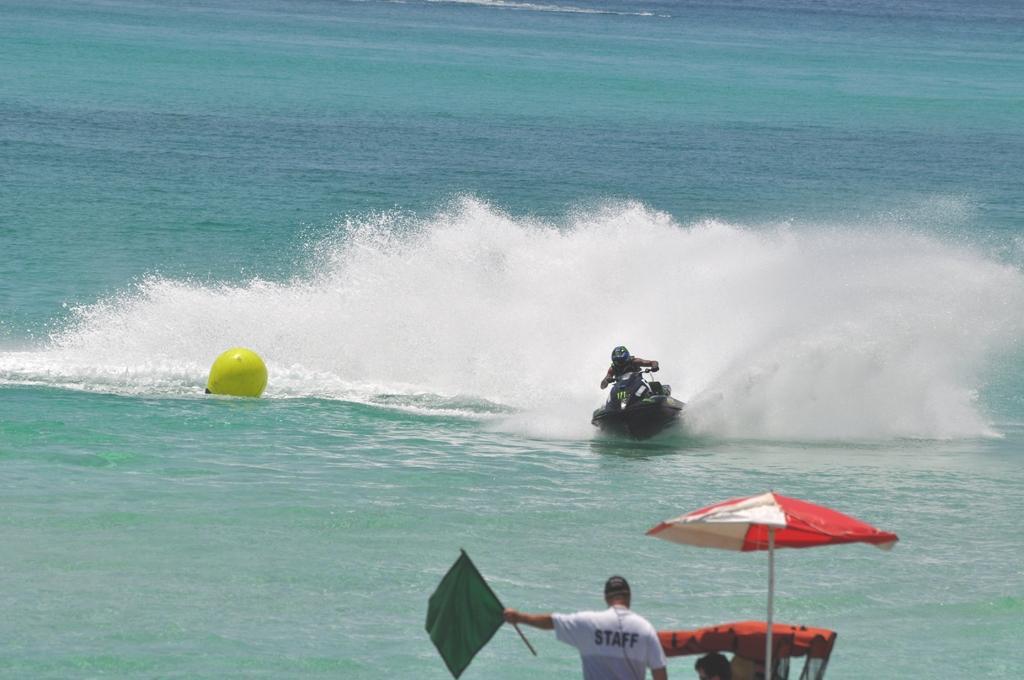Could you give a brief overview of what you see in this image? In this image I can see a person standing at the front, holding a flag. There is an umbrella on the right. A person is riding a speedboat on the water. 